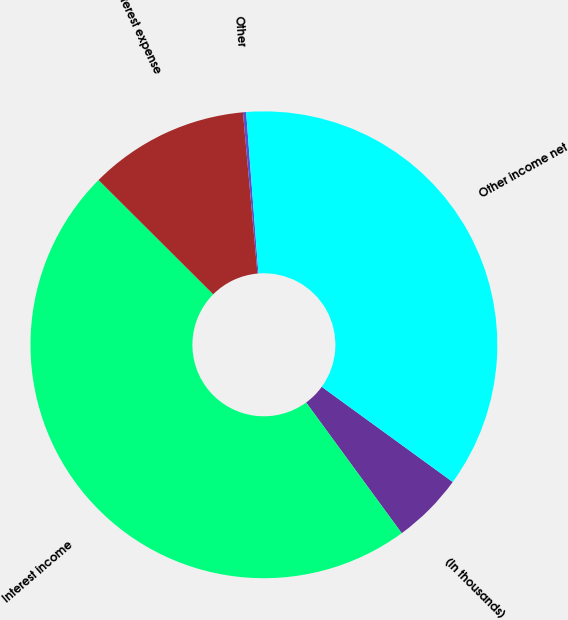<chart> <loc_0><loc_0><loc_500><loc_500><pie_chart><fcel>(In thousands)<fcel>Interest income<fcel>Interest expense<fcel>Other<fcel>Other income net<nl><fcel>4.95%<fcel>47.52%<fcel>11.1%<fcel>0.22%<fcel>36.21%<nl></chart> 